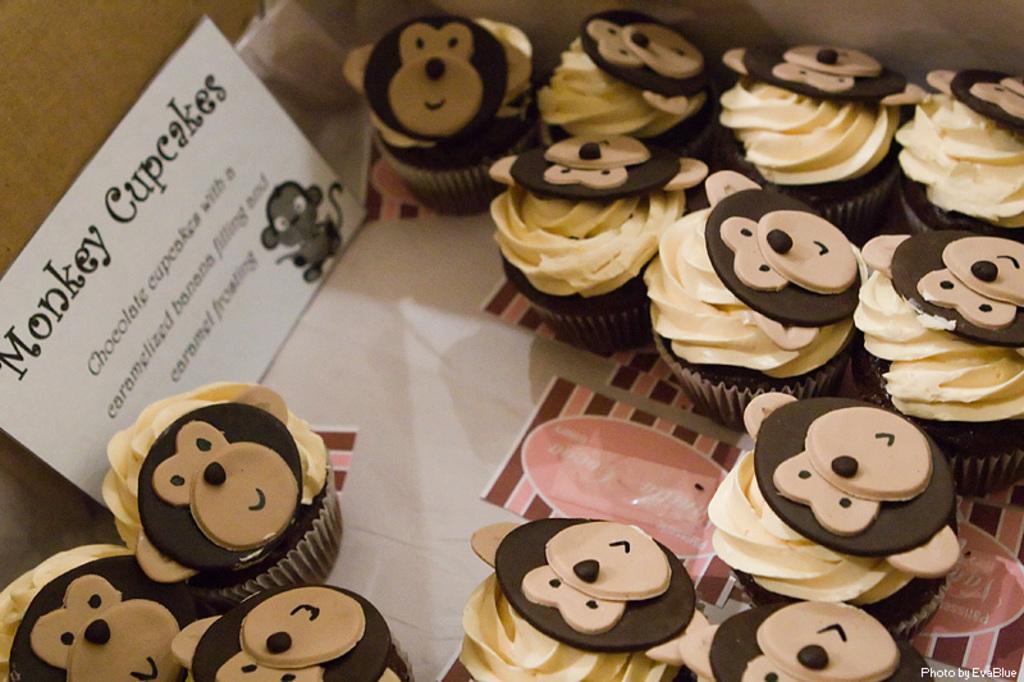Please provide a concise description of this image. In this image we can see cupcakes and a name label beside them. 